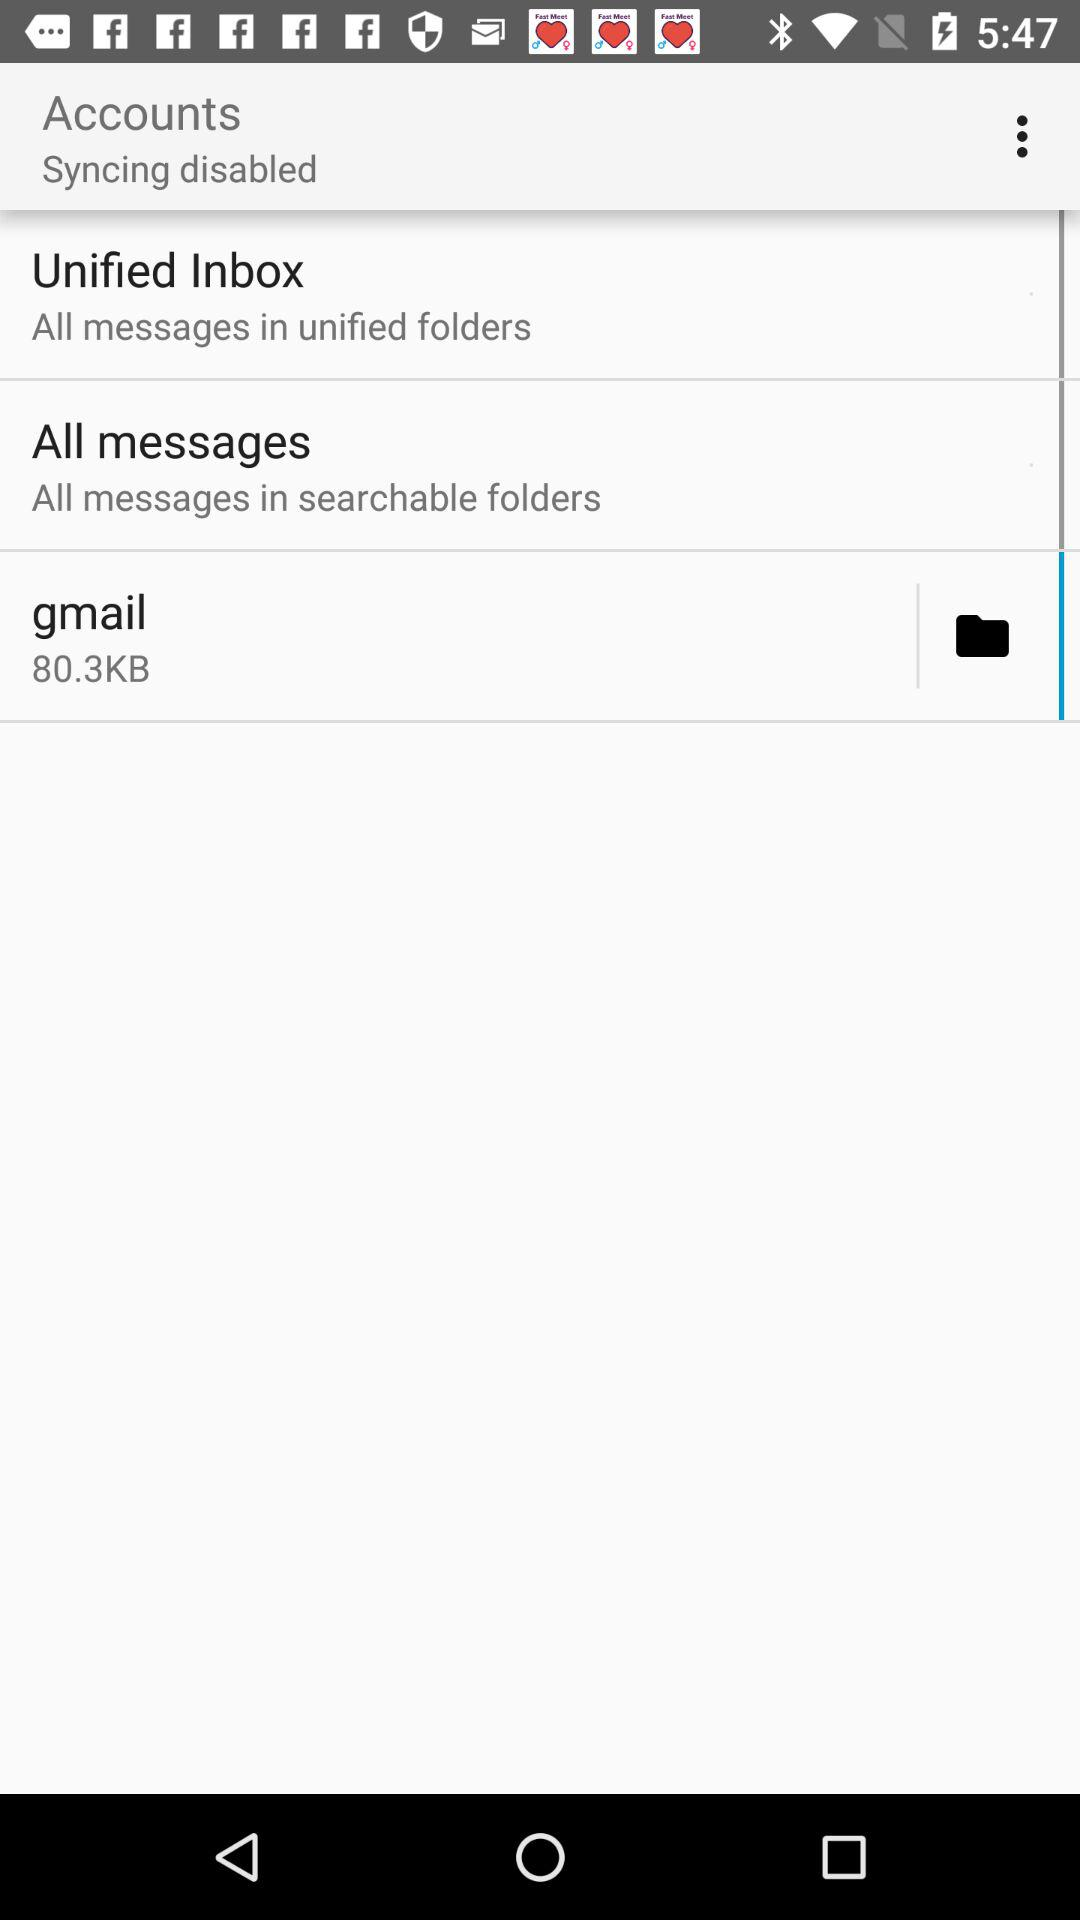How many messages are in the folders?
When the provided information is insufficient, respond with <no answer>. <no answer> 